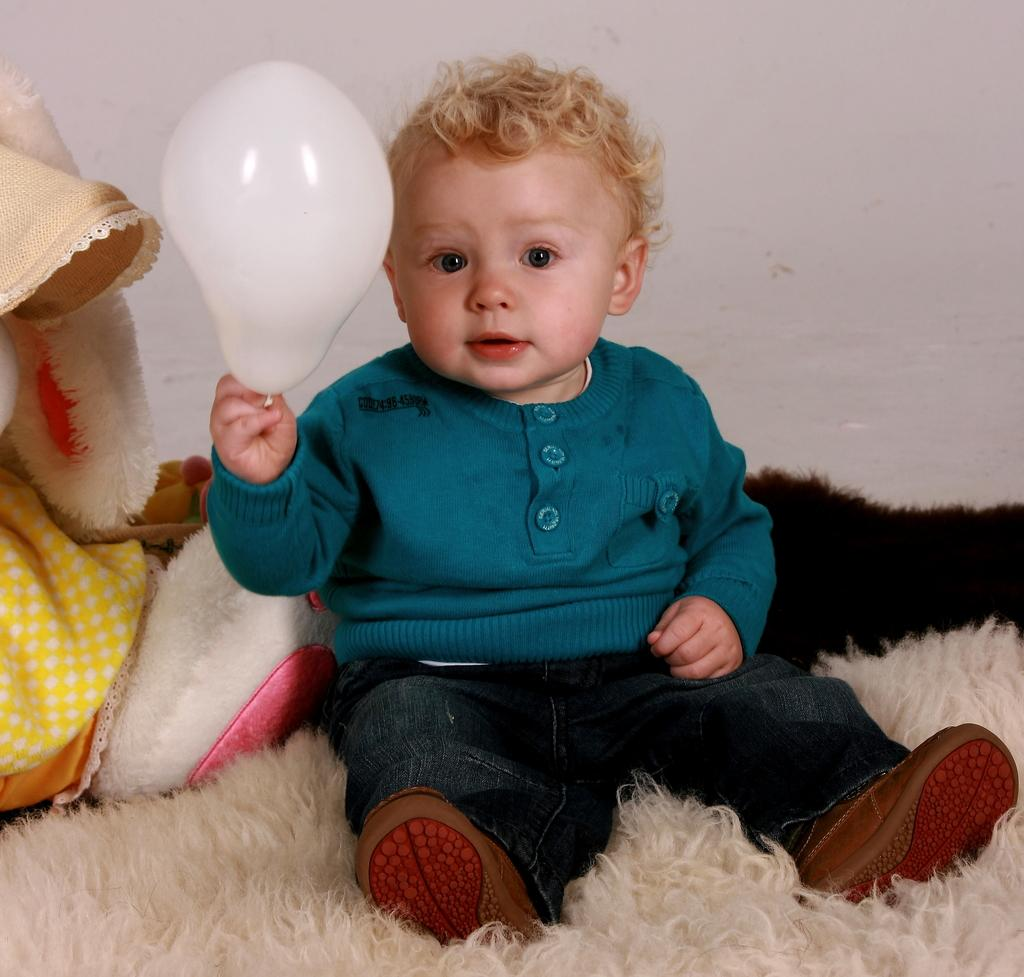Who is the main subject in the image? There is a boy in the image. What is the boy doing in the image? The boy is sitting on a bed. What is the boy holding in the image? The boy is holding a balloon. What can be seen behind the boy in the image? There is a wall behind the boy. What type of collar does the boy's uncle wear in the image? There is no uncle or collar present in the image. What grade is the boy in based on the image? The image does not provide any information about the boy's grade. 